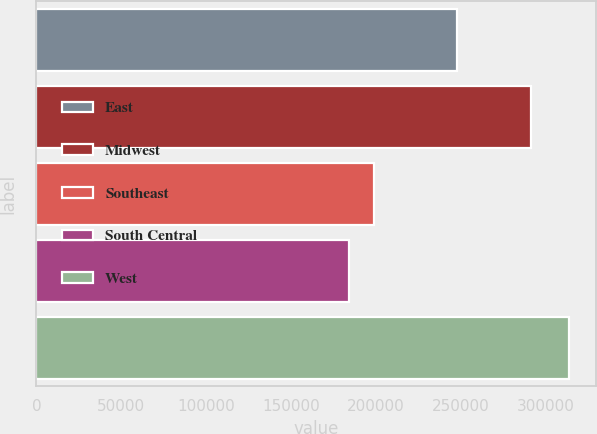Convert chart to OTSL. <chart><loc_0><loc_0><loc_500><loc_500><bar_chart><fcel>East<fcel>Midwest<fcel>Southeast<fcel>South Central<fcel>West<nl><fcel>248000<fcel>291500<fcel>198800<fcel>183900<fcel>314000<nl></chart> 